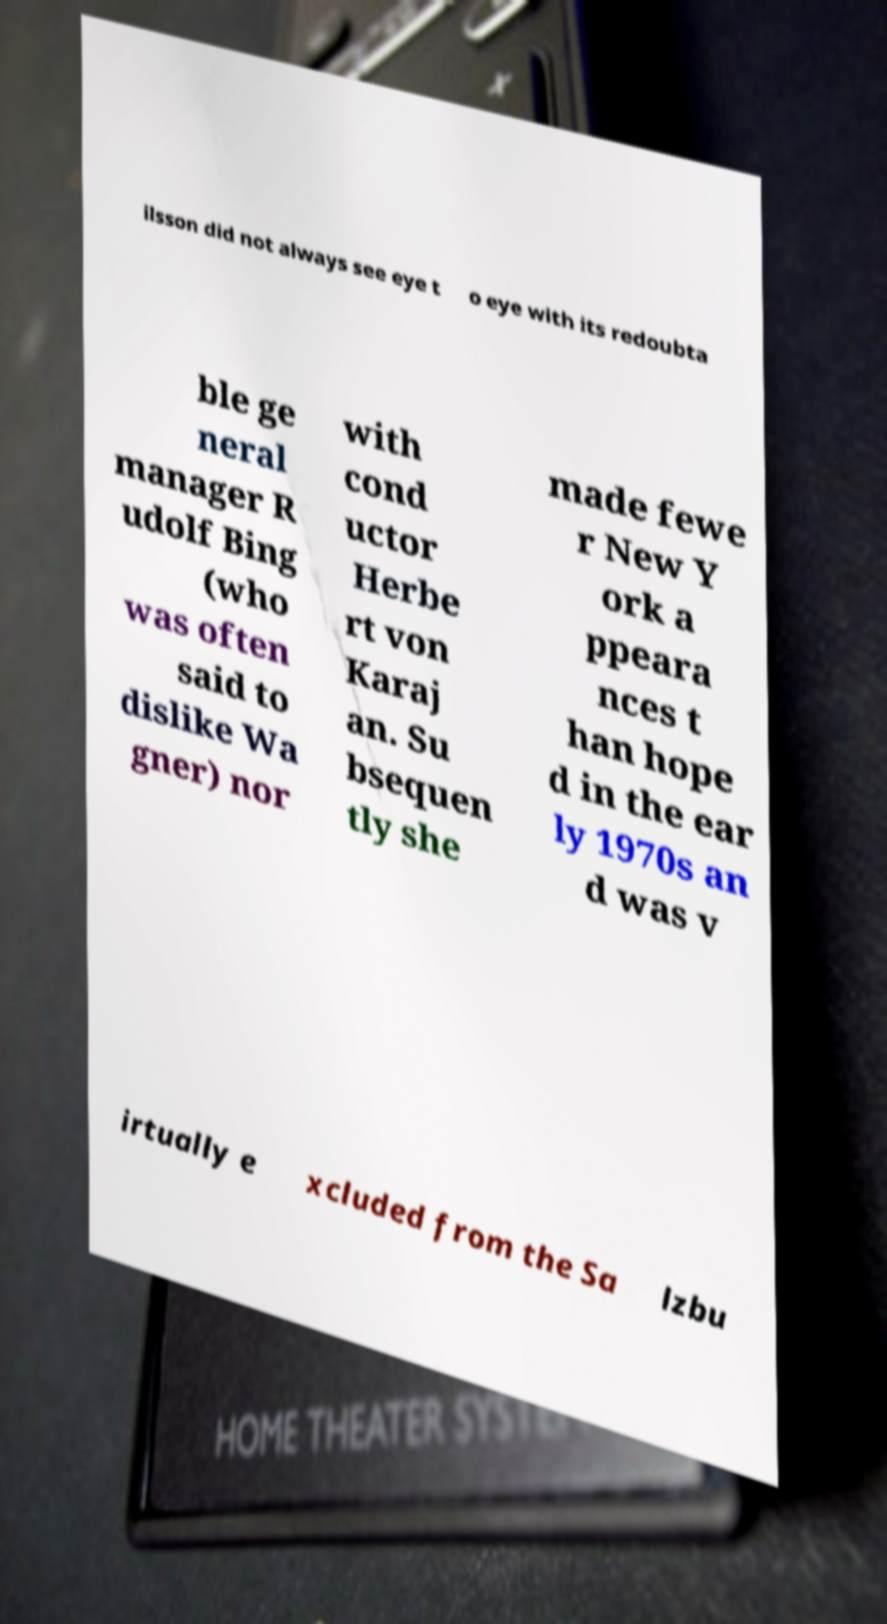Can you read and provide the text displayed in the image?This photo seems to have some interesting text. Can you extract and type it out for me? ilsson did not always see eye t o eye with its redoubta ble ge neral manager R udolf Bing (who was often said to dislike Wa gner) nor with cond uctor Herbe rt von Karaj an. Su bsequen tly she made fewe r New Y ork a ppeara nces t han hope d in the ear ly 1970s an d was v irtually e xcluded from the Sa lzbu 